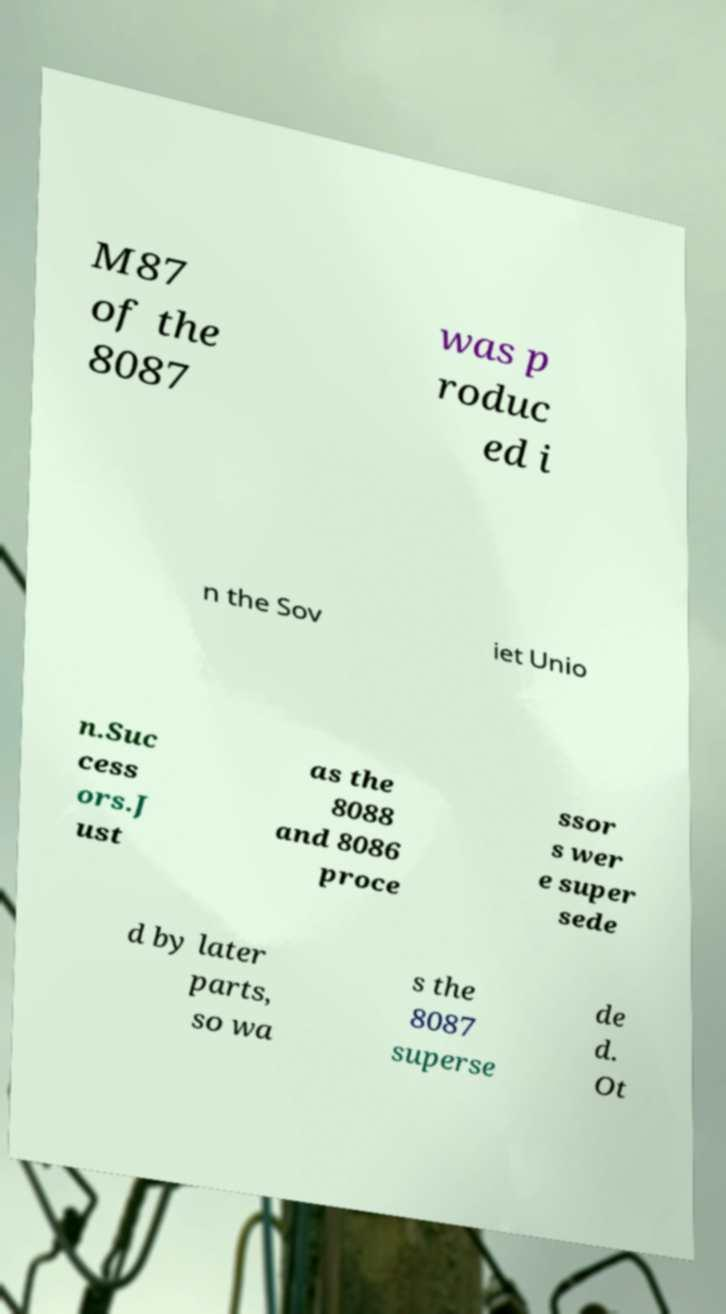What messages or text are displayed in this image? I need them in a readable, typed format. M87 of the 8087 was p roduc ed i n the Sov iet Unio n.Suc cess ors.J ust as the 8088 and 8086 proce ssor s wer e super sede d by later parts, so wa s the 8087 superse de d. Ot 